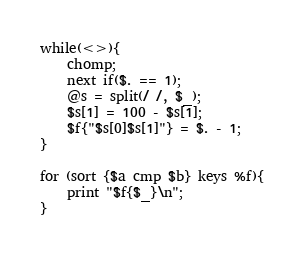<code> <loc_0><loc_0><loc_500><loc_500><_Perl_>while(<>){
	chomp;
	next if($. == 1);
	@s = split(/ /, $_);
	$s[1] = 100 - $s[1];
	$f{"$s[0]$s[1]"} = $. - 1;
}

for (sort {$a cmp $b} keys %f){
	print "$f{$_}\n";
}</code> 